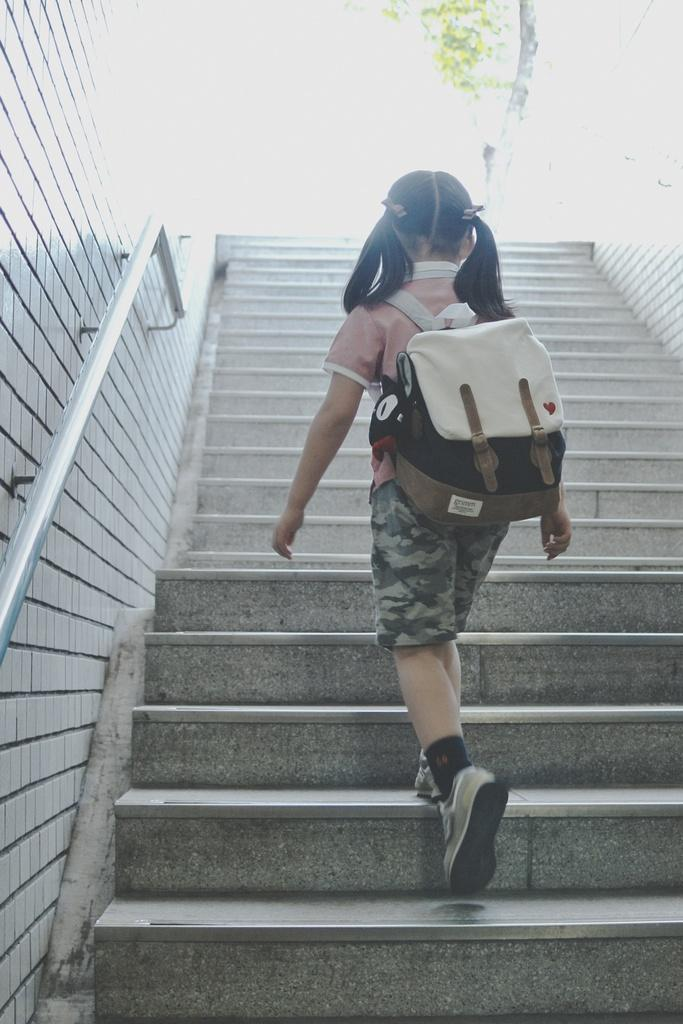What can be seen in the image that allows for vertical movement? There are staircases in the image. What is the girl doing in the image? A girl is climbing the stairs. What is the girl carrying while climbing the stairs? The girl is carrying a bag. Reasoning: Let's think step by breaking down the image into its main components. We start by identifying the staircases, which are the primary means of vertical movement in the image. Then, we focus on the girl and her actions, noting that she is climbing the stairs and carrying a bag. Each question is designed to elicit a specific detail about the image that is known from the provided facts. Absurd Question/Answer: What type of cable can be seen connecting the playground equipment in the image? There is no playground equipment or cable present in the image; it features staircases and a girl climbing them. What industry is depicted in the image? The image does not depict any specific industry; it shows a girl climbing stairs. 